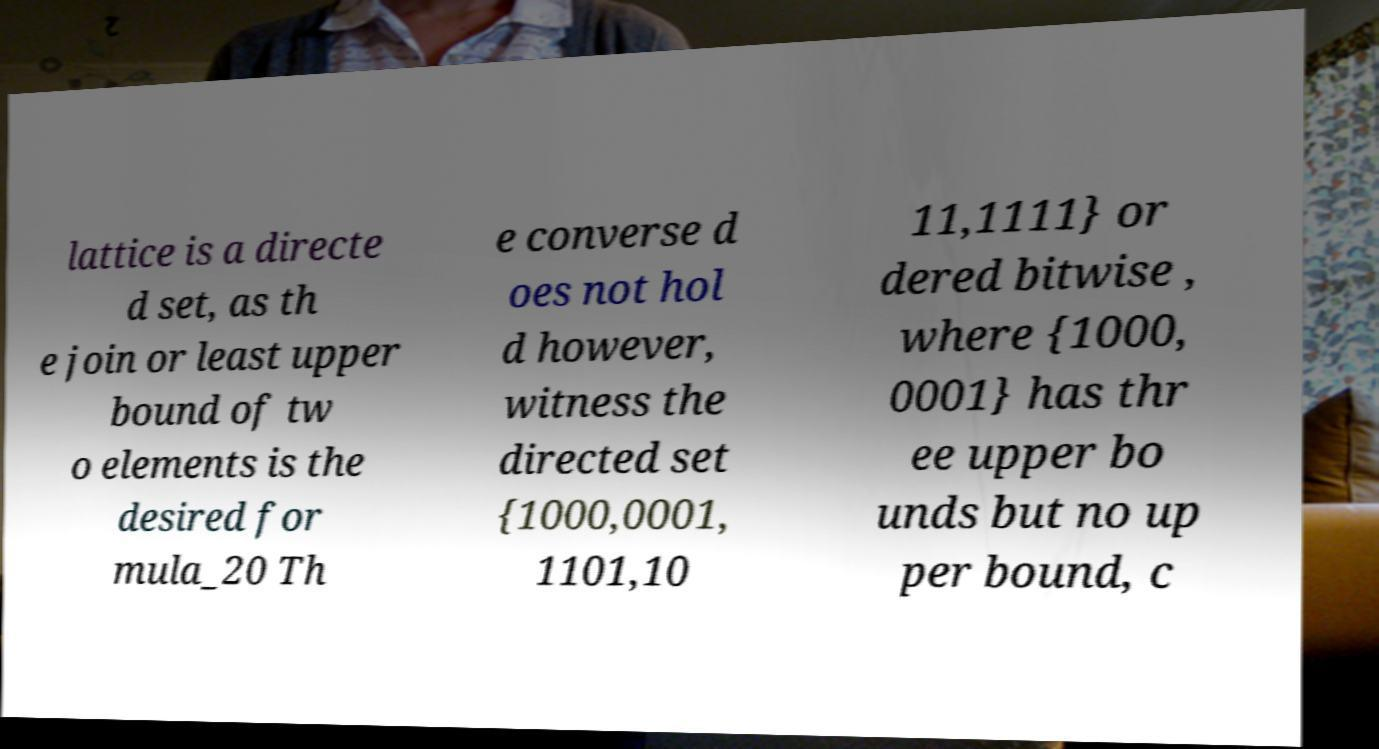For documentation purposes, I need the text within this image transcribed. Could you provide that? lattice is a directe d set, as th e join or least upper bound of tw o elements is the desired for mula_20 Th e converse d oes not hol d however, witness the directed set {1000,0001, 1101,10 11,1111} or dered bitwise , where {1000, 0001} has thr ee upper bo unds but no up per bound, c 